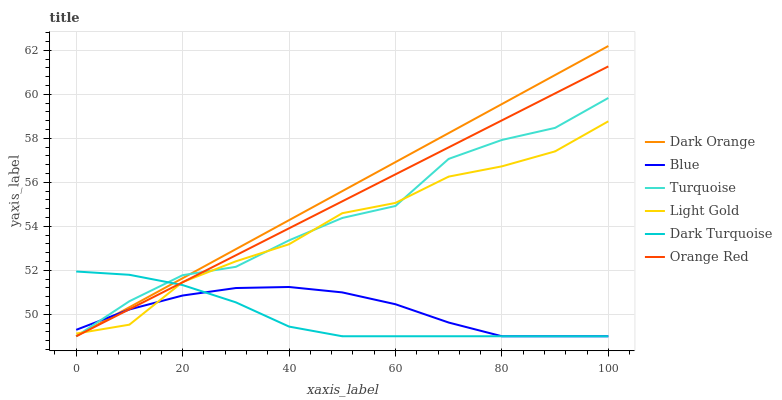Does Dark Turquoise have the minimum area under the curve?
Answer yes or no. Yes. Does Dark Orange have the maximum area under the curve?
Answer yes or no. Yes. Does Turquoise have the minimum area under the curve?
Answer yes or no. No. Does Turquoise have the maximum area under the curve?
Answer yes or no. No. Is Dark Orange the smoothest?
Answer yes or no. Yes. Is Turquoise the roughest?
Answer yes or no. Yes. Is Turquoise the smoothest?
Answer yes or no. No. Is Dark Orange the roughest?
Answer yes or no. No. Does Blue have the lowest value?
Answer yes or no. Yes. Does Light Gold have the lowest value?
Answer yes or no. No. Does Dark Orange have the highest value?
Answer yes or no. Yes. Does Turquoise have the highest value?
Answer yes or no. No. Does Orange Red intersect Blue?
Answer yes or no. Yes. Is Orange Red less than Blue?
Answer yes or no. No. Is Orange Red greater than Blue?
Answer yes or no. No. 